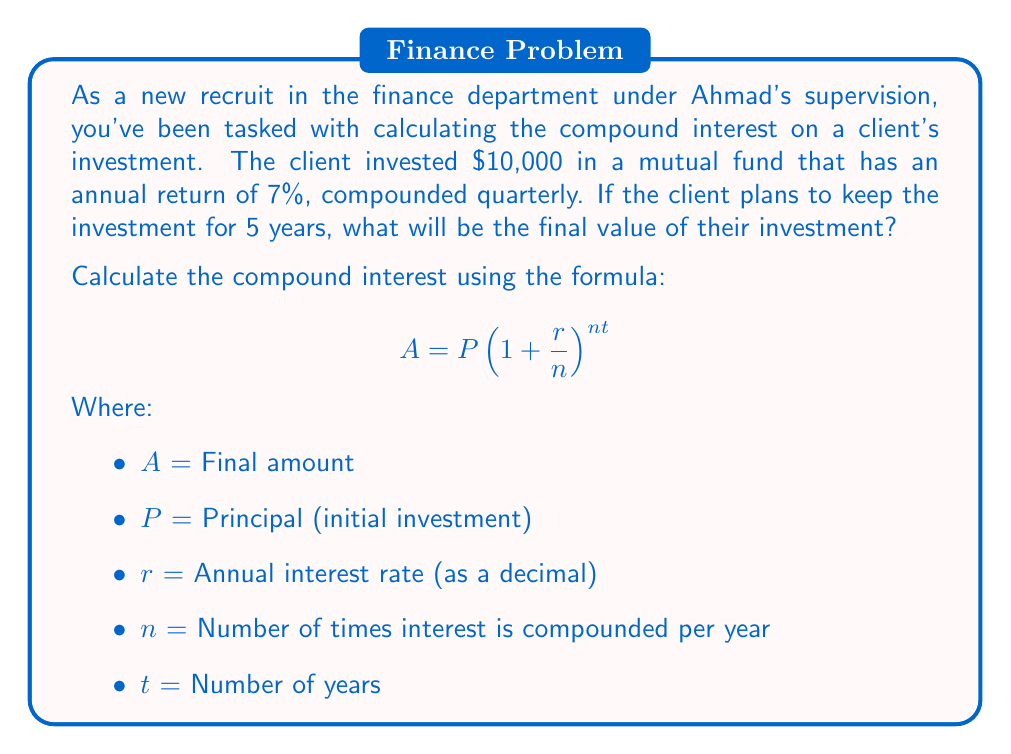Can you answer this question? Let's break down the problem and solve it step by step:

1. Identify the given values:
   $P = 10,000$ (initial investment)
   $r = 0.07$ (7% annual return as a decimal)
   $n = 4$ (compounded quarterly, so 4 times per year)
   $t = 5$ (5-year investment period)

2. Plug these values into the compound interest formula:

   $$A = 10,000(1 + \frac{0.07}{4})^{4 \times 5}$$

3. Simplify the expression inside the parentheses:

   $$A = 10,000(1 + 0.0175)^{20}$$

4. Calculate the value inside the parentheses:

   $$A = 10,000(1.0175)^{20}$$

5. Use a calculator to compute $(1.0175)^{20}$:

   $$A = 10,000 \times 1.4185745$$

6. Multiply to get the final amount:

   $$A = 14,185.75$$

The final value of the investment after 5 years will be $14,185.75.

To calculate the compound interest earned, subtract the initial investment from the final amount:

Compound Interest = $14,185.75 - $10,000 = $4,185.75
Answer: The final value of the investment after 5 years will be $14,185.75, and the compound interest earned is $4,185.75. 